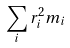<formula> <loc_0><loc_0><loc_500><loc_500>\sum _ { i } r _ { i } ^ { 2 } m _ { i }</formula> 